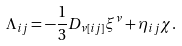<formula> <loc_0><loc_0><loc_500><loc_500>\Lambda _ { i j } = - \frac { 1 } { 3 } D _ { \nu [ i j ] } \xi ^ { \nu } + \eta _ { i j } \chi .</formula> 